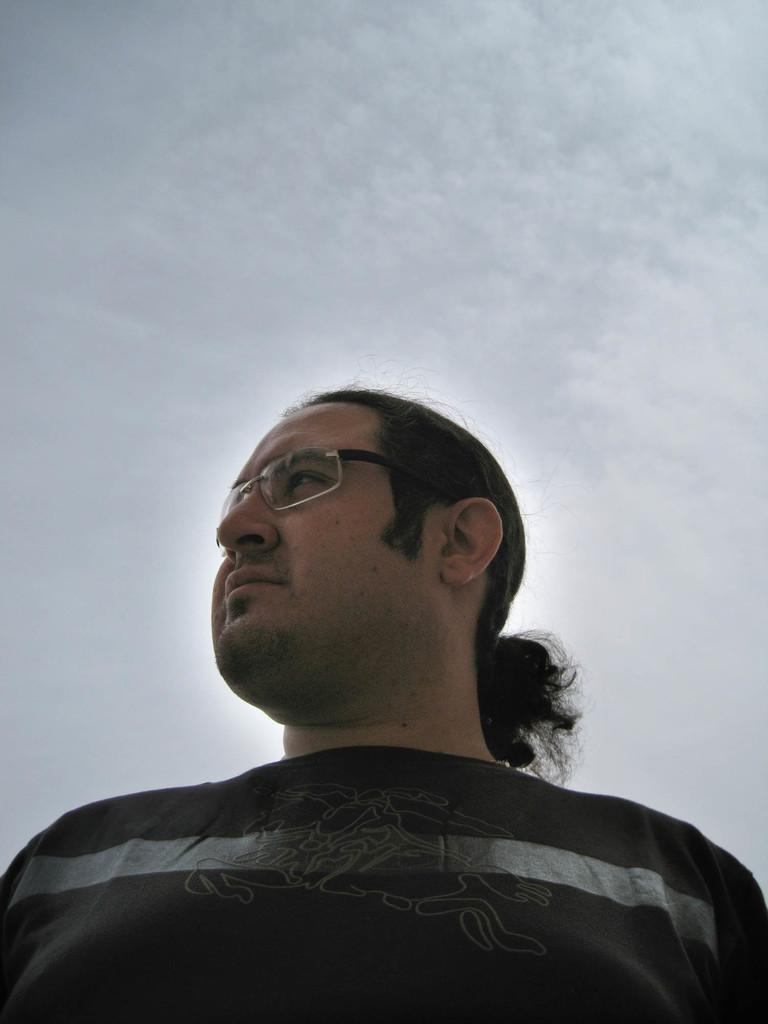What can be seen in the image? There is a person in the image. What is the person wearing? The person is wearing a t-shirt and spectacles. What is the person doing in the image? The person is watching something. What can be seen in the background of the image? There are clouds in the sky in the background of the image. What type of clam is being used as a prop in the image? There is no clam present in the image. How does the person start their activity in the image? The image does not show the person starting their activity, only the person watching something. 